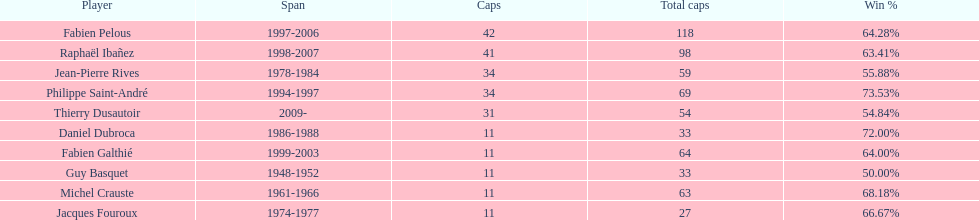Which captain served the least amount of time? Daniel Dubroca. 